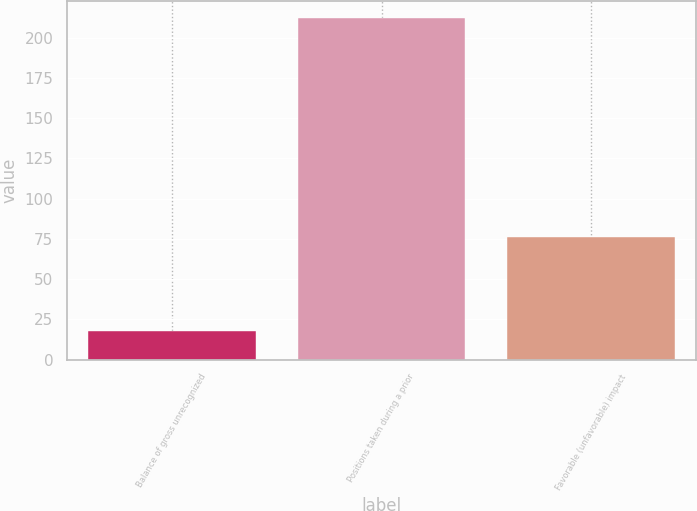Convert chart to OTSL. <chart><loc_0><loc_0><loc_500><loc_500><bar_chart><fcel>Balance of gross unrecognized<fcel>Positions taken during a prior<fcel>Favorable (unfavorable) impact<nl><fcel>18<fcel>212<fcel>76<nl></chart> 